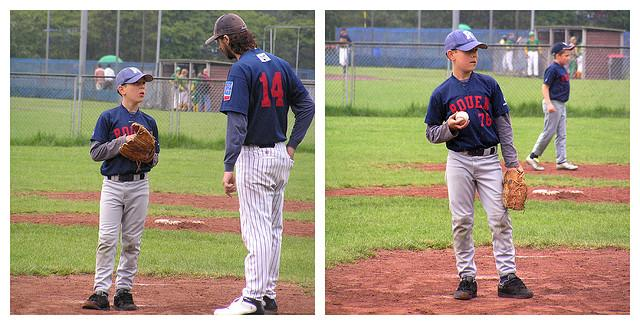What color is the text for this jersey of the boy playing baseball? Please explain your reasoning. red. The text is bright red on the shirt. 